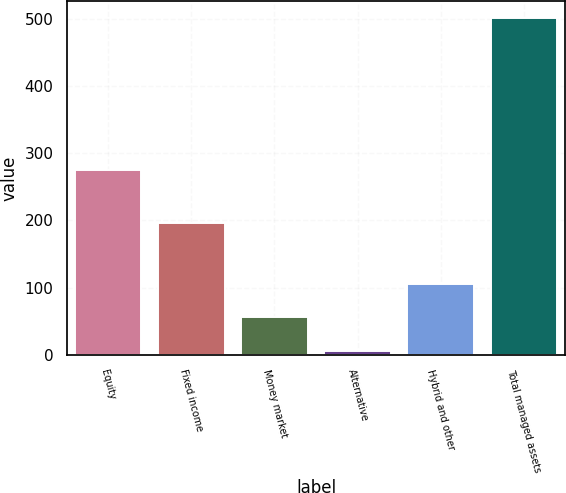<chart> <loc_0><loc_0><loc_500><loc_500><bar_chart><fcel>Equity<fcel>Fixed income<fcel>Money market<fcel>Alternative<fcel>Hybrid and other<fcel>Total managed assets<nl><fcel>275.3<fcel>196.4<fcel>55.84<fcel>6.4<fcel>105.28<fcel>500.8<nl></chart> 